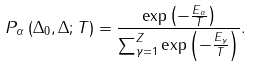<formula> <loc_0><loc_0><loc_500><loc_500>P _ { \alpha } \left ( \Delta _ { 0 } , \Delta ; T \right ) = \frac { \exp \left ( - \frac { E _ { \alpha } } { T } \right ) } { \sum _ { \gamma = 1 } ^ { Z } \exp \left ( - \frac { E _ { \gamma } } { T } \right ) } .</formula> 